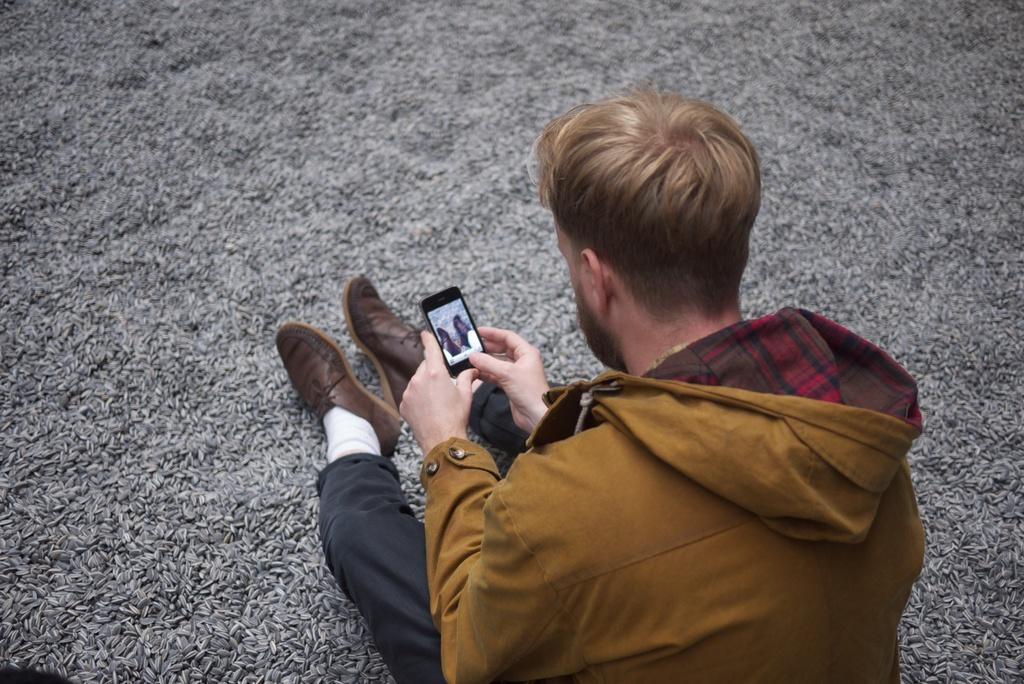Who is present in the image? There is a man in the image. What is the man doing in the image? The man is sitting on the floor and capturing an image. What type of roof can be seen in the image? There is no roof present in the image; the man is sitting on the floor. What achievements has the man accomplished in the image? The image does not provide information about the man's achievements; it only shows him sitting on the floor and capturing an image. 